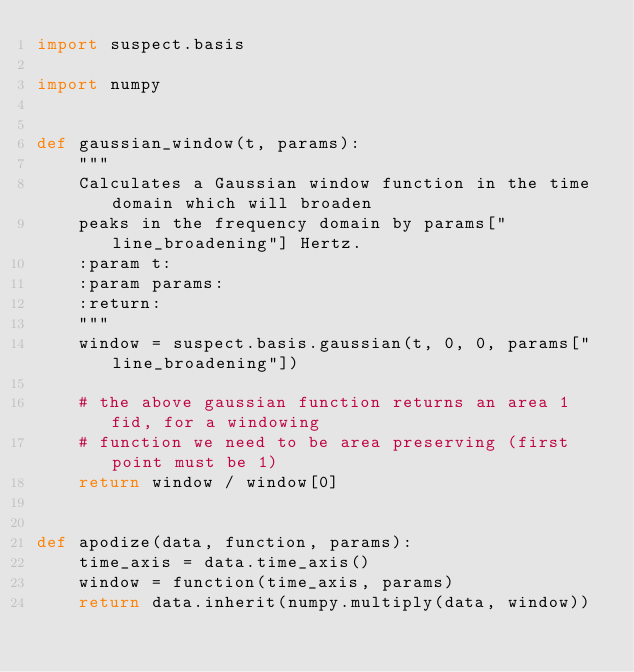<code> <loc_0><loc_0><loc_500><loc_500><_Python_>import suspect.basis

import numpy


def gaussian_window(t, params):
    """
    Calculates a Gaussian window function in the time domain which will broaden
    peaks in the frequency domain by params["line_broadening"] Hertz.
    :param t:
    :param params:
    :return:
    """
    window = suspect.basis.gaussian(t, 0, 0, params["line_broadening"])

    # the above gaussian function returns an area 1 fid, for a windowing
    # function we need to be area preserving (first point must be 1)
    return window / window[0]


def apodize(data, function, params):
    time_axis = data.time_axis()
    window = function(time_axis, params)
    return data.inherit(numpy.multiply(data, window))
</code> 